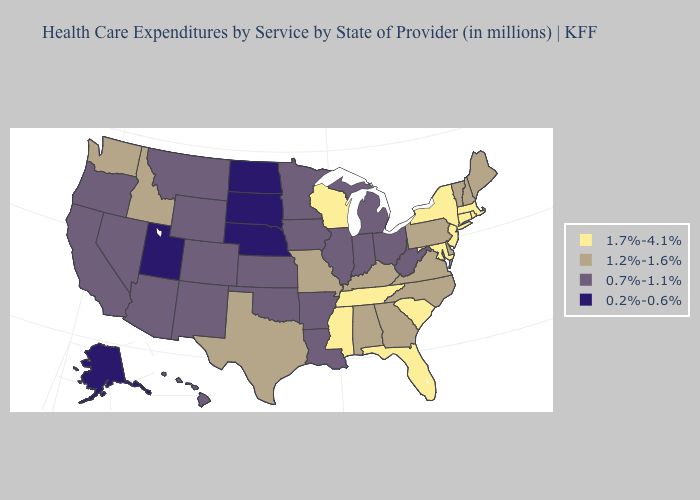What is the value of Oklahoma?
Write a very short answer. 0.7%-1.1%. Name the states that have a value in the range 0.7%-1.1%?
Be succinct. Arizona, Arkansas, California, Colorado, Hawaii, Illinois, Indiana, Iowa, Kansas, Louisiana, Michigan, Minnesota, Montana, Nevada, New Mexico, Ohio, Oklahoma, Oregon, West Virginia, Wyoming. Name the states that have a value in the range 1.7%-4.1%?
Keep it brief. Connecticut, Florida, Maryland, Massachusetts, Mississippi, New Jersey, New York, Rhode Island, South Carolina, Tennessee, Wisconsin. Does New Jersey have the highest value in the USA?
Concise answer only. Yes. Name the states that have a value in the range 0.2%-0.6%?
Keep it brief. Alaska, Nebraska, North Dakota, South Dakota, Utah. Does the first symbol in the legend represent the smallest category?
Answer briefly. No. Which states hav the highest value in the Northeast?
Keep it brief. Connecticut, Massachusetts, New Jersey, New York, Rhode Island. Among the states that border Kentucky , which have the highest value?
Be succinct. Tennessee. Does Michigan have the lowest value in the USA?
Be succinct. No. Does Alabama have the highest value in the USA?
Quick response, please. No. Name the states that have a value in the range 1.7%-4.1%?
Quick response, please. Connecticut, Florida, Maryland, Massachusetts, Mississippi, New Jersey, New York, Rhode Island, South Carolina, Tennessee, Wisconsin. Does Missouri have a lower value than New York?
Write a very short answer. Yes. Is the legend a continuous bar?
Concise answer only. No. Does South Dakota have the lowest value in the USA?
Answer briefly. Yes. Is the legend a continuous bar?
Short answer required. No. 